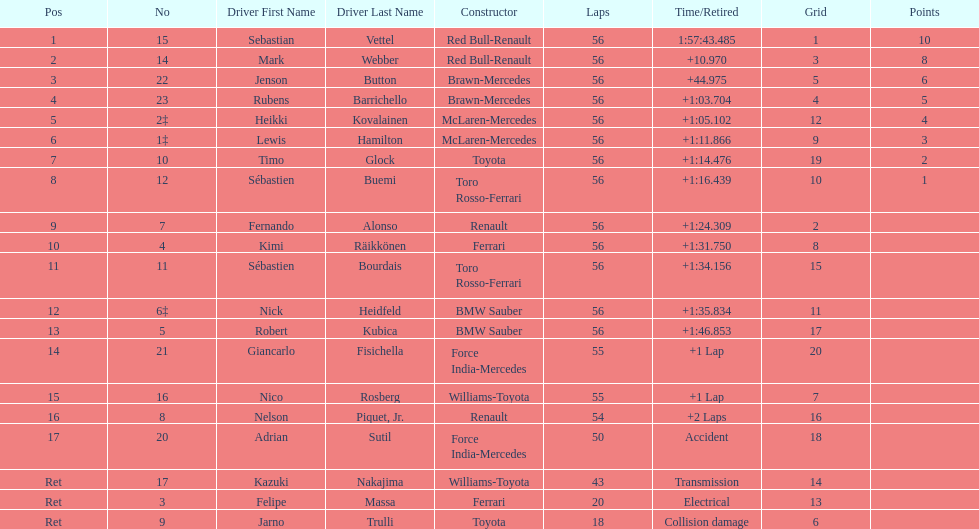Help me parse the entirety of this table. {'header': ['Pos', 'No', 'Driver First Name', 'Driver Last Name', 'Constructor', 'Laps', 'Time/Retired', 'Grid', 'Points'], 'rows': [['1', '15', 'Sebastian', 'Vettel', 'Red Bull-Renault', '56', '1:57:43.485', '1', '10'], ['2', '14', 'Mark', 'Webber', 'Red Bull-Renault', '56', '+10.970', '3', '8'], ['3', '22', 'Jenson', 'Button', 'Brawn-Mercedes', '56', '+44.975', '5', '6'], ['4', '23', 'Rubens', 'Barrichello', 'Brawn-Mercedes', '56', '+1:03.704', '4', '5'], ['5', '2‡', 'Heikki', 'Kovalainen', 'McLaren-Mercedes', '56', '+1:05.102', '12', '4'], ['6', '1‡', 'Lewis', 'Hamilton', 'McLaren-Mercedes', '56', '+1:11.866', '9', '3'], ['7', '10', 'Timo', 'Glock', 'Toyota', '56', '+1:14.476', '19', '2'], ['8', '12', 'Sébastien', 'Buemi', 'Toro Rosso-Ferrari', '56', '+1:16.439', '10', '1'], ['9', '7', 'Fernando', 'Alonso', 'Renault', '56', '+1:24.309', '2', ''], ['10', '4', 'Kimi', 'Räikkönen', 'Ferrari', '56', '+1:31.750', '8', ''], ['11', '11', 'Sébastien', 'Bourdais', 'Toro Rosso-Ferrari', '56', '+1:34.156', '15', ''], ['12', '6‡', 'Nick', 'Heidfeld', 'BMW Sauber', '56', '+1:35.834', '11', ''], ['13', '5', 'Robert', 'Kubica', 'BMW Sauber', '56', '+1:46.853', '17', ''], ['14', '21', 'Giancarlo', 'Fisichella', 'Force India-Mercedes', '55', '+1 Lap', '20', ''], ['15', '16', 'Nico', 'Rosberg', 'Williams-Toyota', '55', '+1 Lap', '7', ''], ['16', '8', 'Nelson', 'Piquet, Jr.', 'Renault', '54', '+2 Laps', '16', ''], ['17', '20', 'Adrian', 'Sutil', 'Force India-Mercedes', '50', 'Accident', '18', ''], ['Ret', '17', 'Kazuki', 'Nakajima', 'Williams-Toyota', '43', 'Transmission', '14', ''], ['Ret', '3', 'Felipe', 'Massa', 'Ferrari', '20', 'Electrical', '13', ''], ['Ret', '9', 'Jarno', 'Trulli', 'Toyota', '18', 'Collision damage', '6', '']]} How many laps in total is the race? 56. 